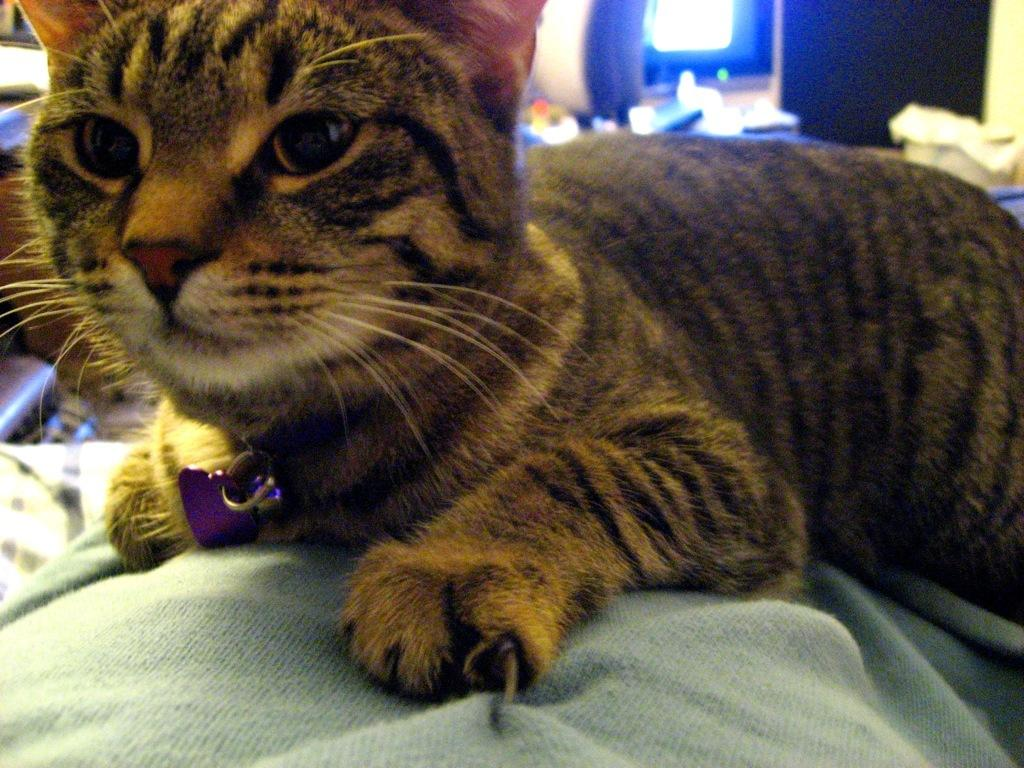What type of animal can be seen in the image? There is a cat in the image. What is the cat lying on? The cat is lying on a cloth. What can be seen in the background of the image? There is a wall, a screen, and a box in the background of the image. Are there any other objects visible in the background? Yes, there are other objects in the background of the image. What type of parent is taking care of the fowl in the image? There is no parent or fowl present in the image; it features a cat lying on a cloth. What material is the plastic used for in the image? There is no plastic present in the image. 